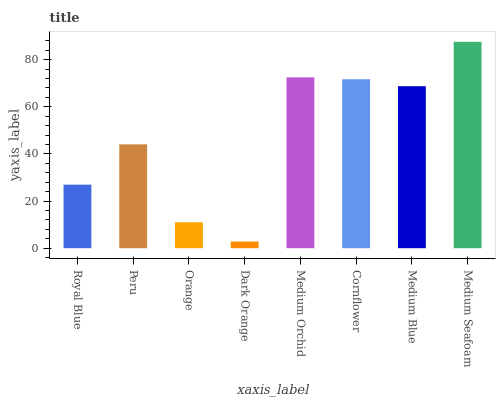Is Peru the minimum?
Answer yes or no. No. Is Peru the maximum?
Answer yes or no. No. Is Peru greater than Royal Blue?
Answer yes or no. Yes. Is Royal Blue less than Peru?
Answer yes or no. Yes. Is Royal Blue greater than Peru?
Answer yes or no. No. Is Peru less than Royal Blue?
Answer yes or no. No. Is Medium Blue the high median?
Answer yes or no. Yes. Is Peru the low median?
Answer yes or no. Yes. Is Orange the high median?
Answer yes or no. No. Is Dark Orange the low median?
Answer yes or no. No. 